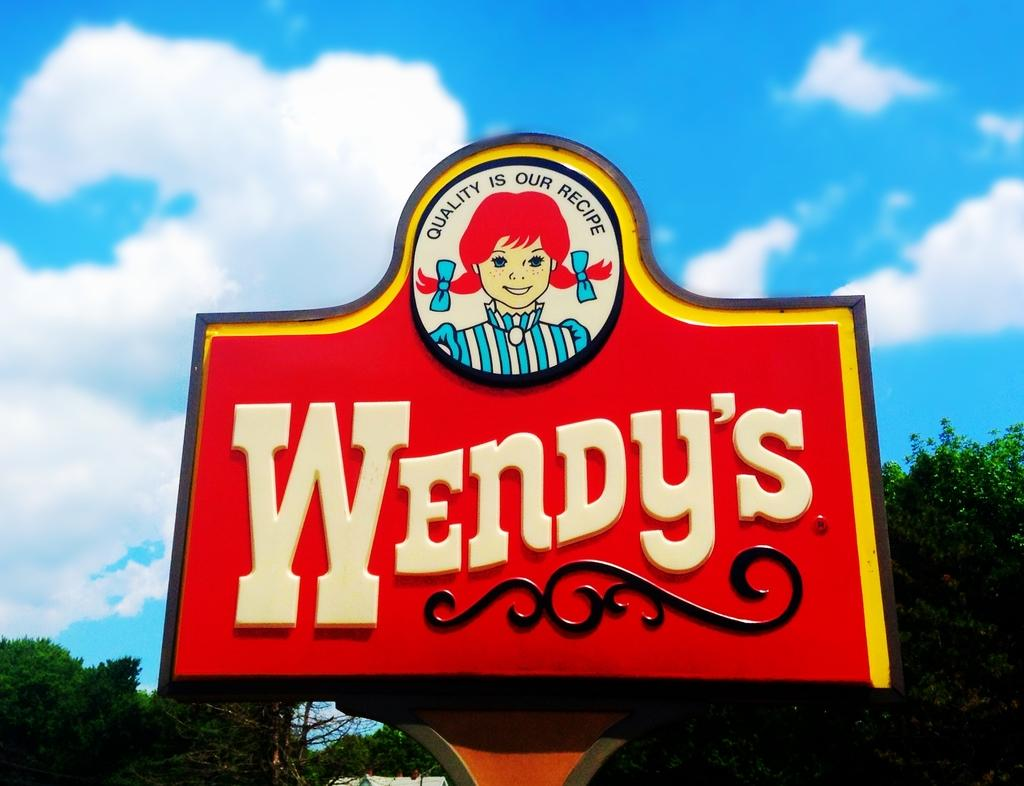What is on the board that is visible in the image? There is a board with text and a picture in the image. What can be seen in the background of the image? There are trees and the sky visible in the background of the image. What is the condition of the sky in the image? Clouds are present in the sky in the image. What type of mint can be seen growing near the trees in the image? There is no mint present in the image; it only features trees and the sky in the background. 